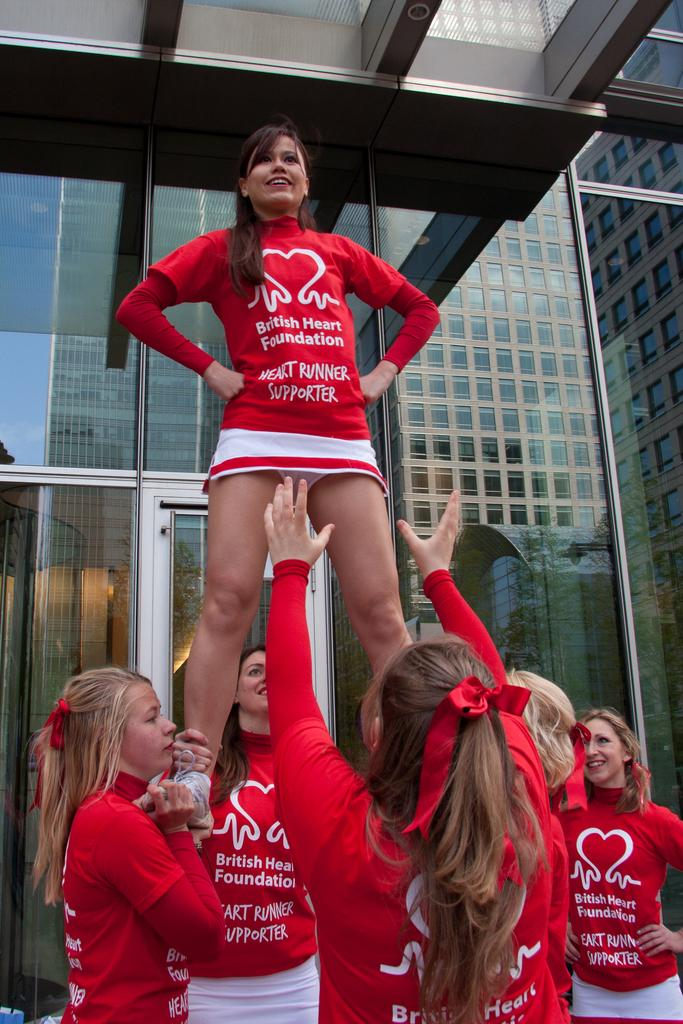<image>
Summarize the visual content of the image. A team of cheerleaders wearing red British Heart Foundation uniforms hold up one of their own. 